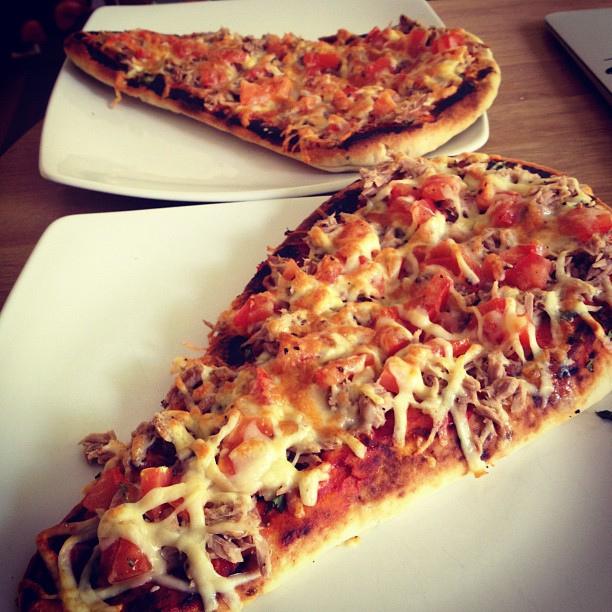What shape are the plates the pizza is on?
Write a very short answer. Square. Is the cheese on the pizza real or fake?
Short answer required. Real. Is the pizza thin crust or thick crust?
Quick response, please. Thin. 